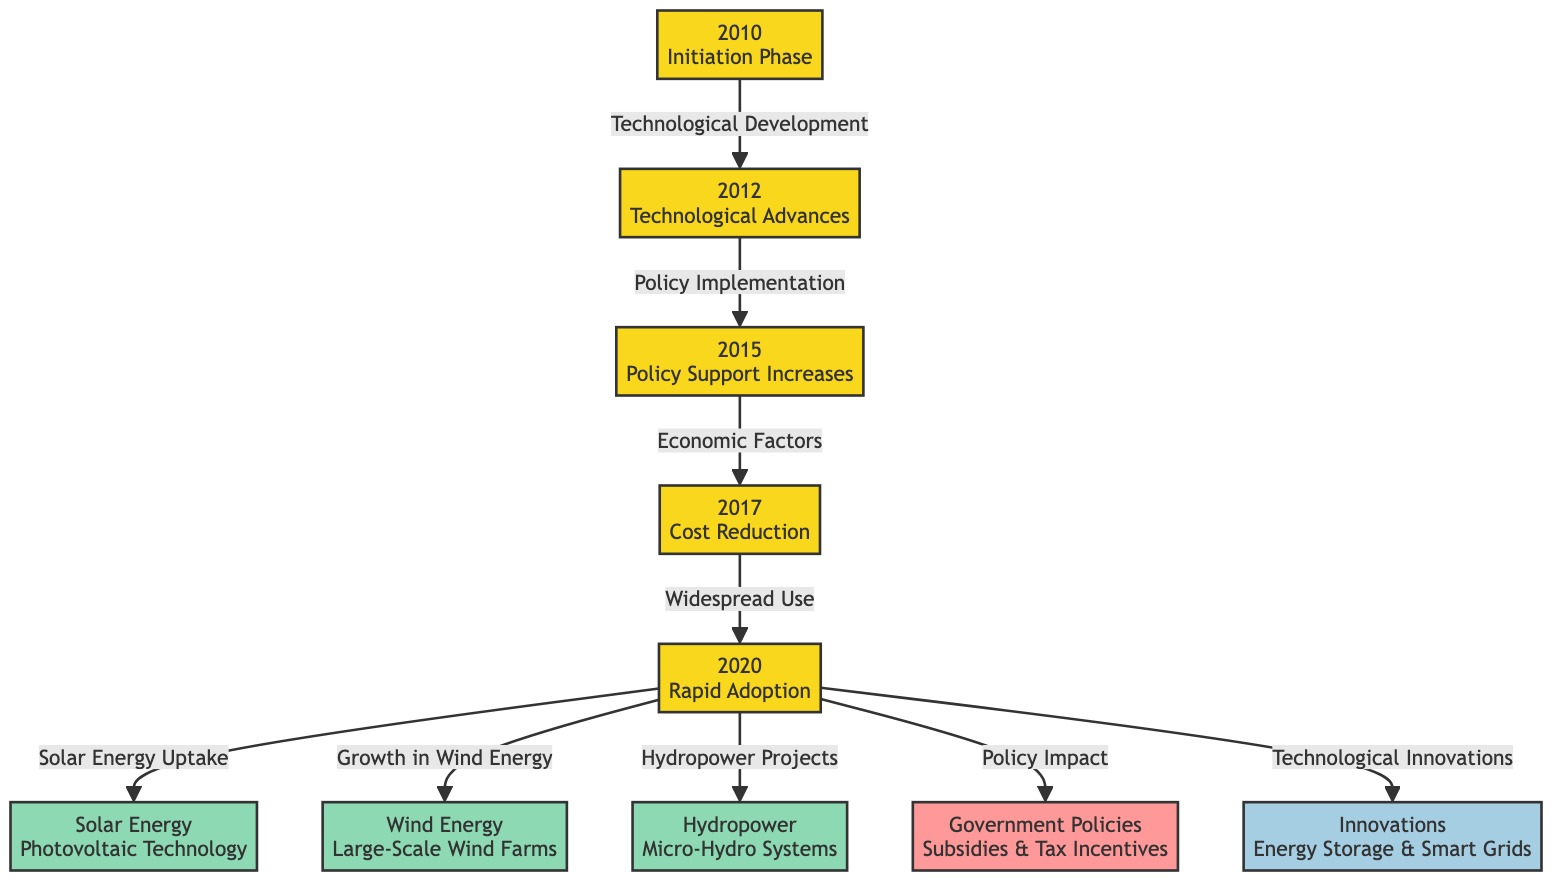What phase began in 2010? The diagram indicates that the phase that began in 2010 is labeled "Initiation Phase." This is identified by node 1, which marks the beginning of the timeline.
Answer: Initiation Phase What is the last year represented in this diagram? The last year shown in the diagram is 2020, as indicated by node 5. This node marks the point of "Rapid Adoption."
Answer: 2020 How many energy types are listed in the diagram? The diagram lists three types of energy, which are Solar Energy, Wind Energy, and Hydropower. These are represented by nodes 6, 7, and 8.
Answer: Three What connects "Cost Reduction" to "Rapid Adoption"? The connection between "Cost Reduction" (node 4) and "Rapid Adoption" (node 5) is labeled "Widespread Use" in the diagram. This shows the progression leading to the rapid adoption phase.
Answer: Widespread Use Which policy type is directly linked to the "Rapid Adoption"? "Government Policies" (node 9) is directly linked to "Rapid Adoption" (node 5) through a line in the diagram, indicating that policy impacts were an important factor in this phase.
Answer: Government Policies What technological innovation is associated with the stage after "Cost Reduction"? Following "Cost Reduction," the next stage that occurs is "Rapid Adoption," which is associated with both "Technological Innovations" (node 10) and a significant increase in renewable energy use.
Answer: Technological Innovations What leads to the "Policy Support Increases"? The "Policy Support Increases" (node 3) is the result of "Technological Development," which connects node 1 to node 2 through the labeled relationship in the flowchart.
Answer: Technological Development Which energy technology is categorized under "Solar Energy"? The diagram specifies "Photovoltaic Technology" as the specific type of technology within the broader category of "Solar Energy," found at node 6.
Answer: Photovoltaic Technology What year did cost reduction occur? The diagram indicates that cost reduction happened in 2017, as represented by node 4 labeled "Cost Reduction."
Answer: 2017 